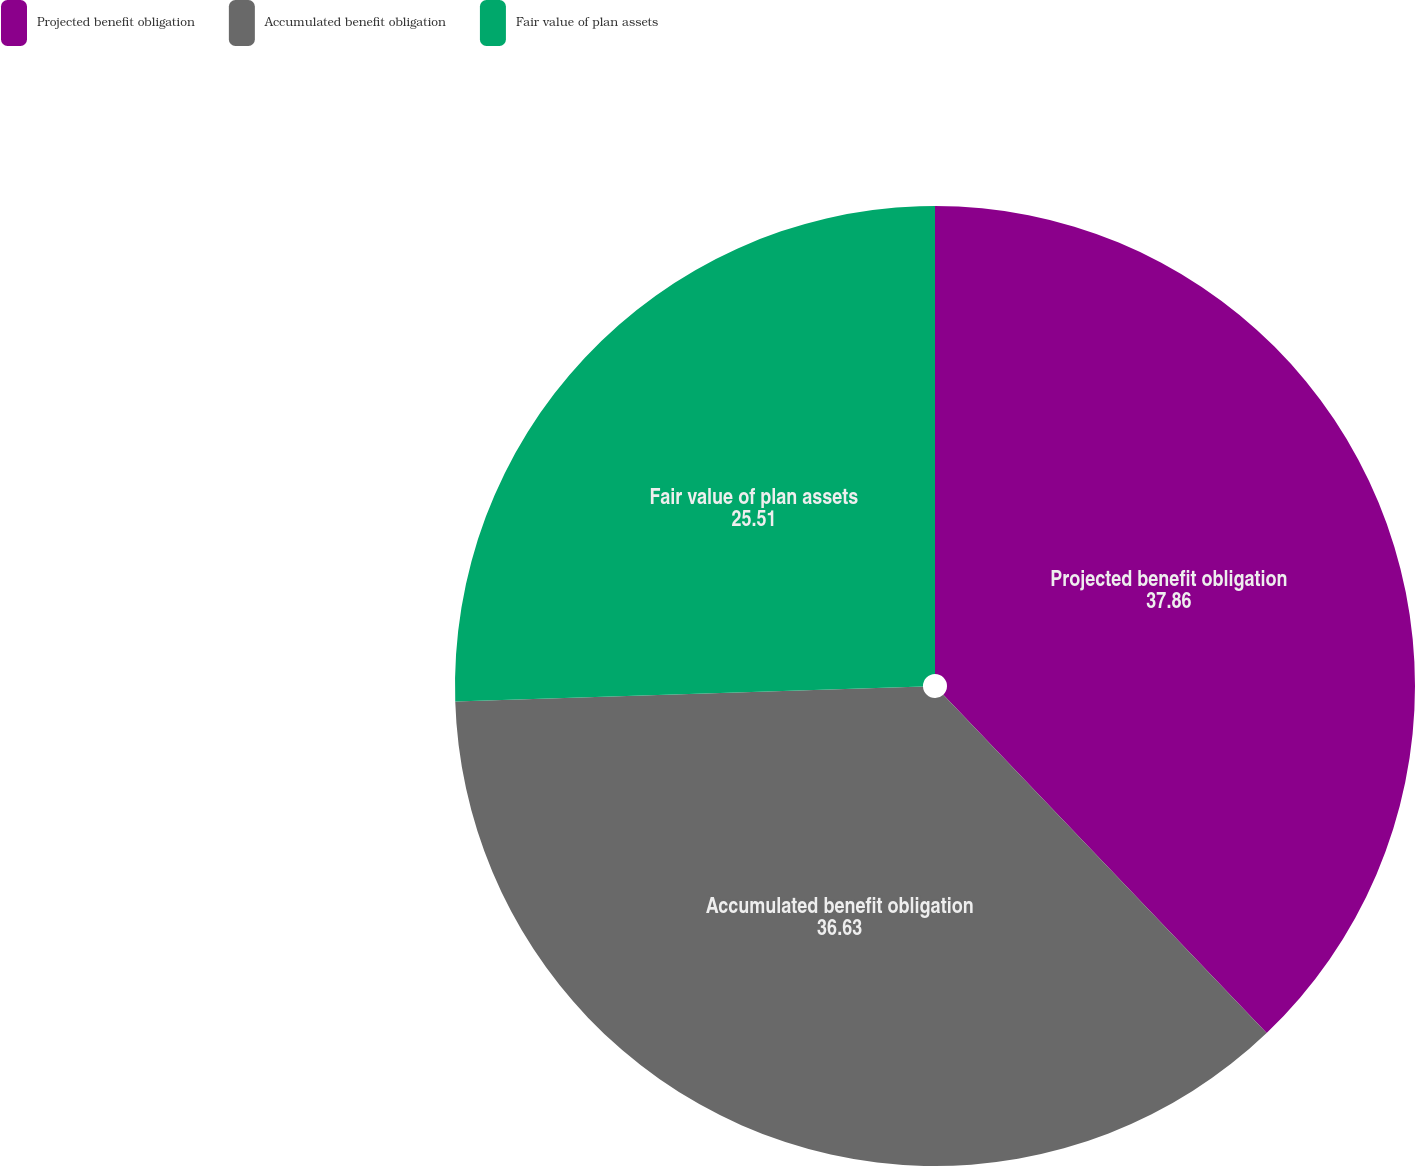<chart> <loc_0><loc_0><loc_500><loc_500><pie_chart><fcel>Projected benefit obligation<fcel>Accumulated benefit obligation<fcel>Fair value of plan assets<nl><fcel>37.86%<fcel>36.63%<fcel>25.51%<nl></chart> 